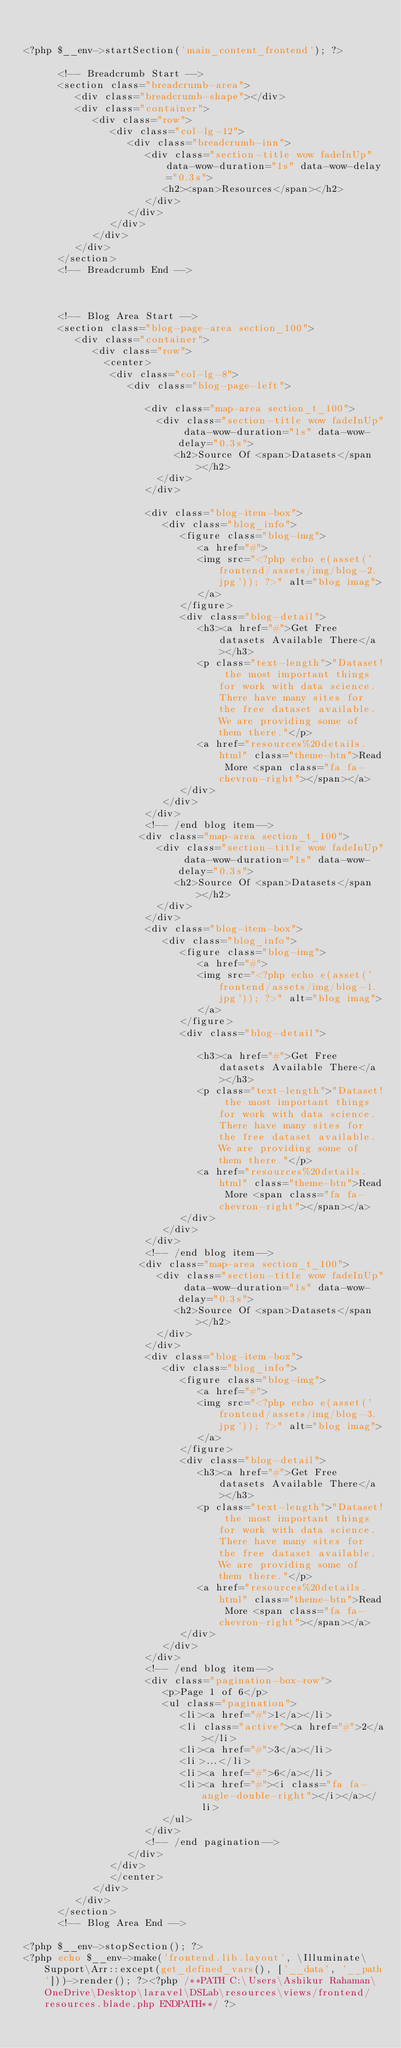Convert code to text. <code><loc_0><loc_0><loc_500><loc_500><_PHP_>

<?php $__env->startSection('main_content_frontend'); ?>

      <!-- Breadcrumb Start -->
      <section class="breadcrumb-area">
         <div class="breadcrumb-shape"></div>
         <div class="container">
            <div class="row">
               <div class="col-lg-12">
                  <div class="breadcrumb-inn">
                     <div class="section-title wow fadeInUp" data-wow-duration="1s" data-wow-delay="0.3s">
                        <h2><span>Resources</span></h2>
                     </div>
                  </div>
               </div>
            </div>
         </div>
      </section>
      <!-- Breadcrumb End -->
       

       
      <!-- Blog Area Start -->
      <section class="blog-page-area section_100">
         <div class="container">
            <div class="row">
              <center>
               <div class="col-lg-8">
                  <div class="blog-page-left">
                    
                     <div class="map-area section_t_100">
                       <div class="section-title wow fadeInUp" data-wow-duration="1s" data-wow-delay="0.3s">
                          <h2>Source Of <span>Datasets</span></h2>
                       </div>
                     </div>
                     
                     <div class="blog-item-box">
                        <div class="blog_info">
                           <figure class="blog-img">
                              <a href="#">
                              <img src="<?php echo e(asset('frontend/assets/img/blog-2.jpg')); ?>" alt="blog imag">
                              </a>
                           </figure>
                           <div class="blog-detail">
                              <h3><a href="#">Get Free datasets Available There</a></h3>
                              <p class="text-length">"Dataset! the most important things for work with data science. There have many sites for the free dataset available. We are providing some of them there."</p>
                              <a href="resources%20details.html" class="theme-btn">Read More <span class="fa fa-chevron-right"></span></a>
                           </div>
                        </div>
                     </div>
                     <!-- /end blog item-->
                    <div class="map-area section_t_100">
                       <div class="section-title wow fadeInUp" data-wow-duration="1s" data-wow-delay="0.3s">
                          <h2>Source Of <span>Datasets</span></h2>
                       </div>
                     </div>
                     <div class="blog-item-box">
                        <div class="blog_info">
                           <figure class="blog-img">
                              <a href="#">
                              <img src="<?php echo e(asset('frontend/assets/img/blog-1.jpg')); ?>" alt="blog imag">
                              </a>
                           </figure>
                           <div class="blog-detail">
                            
                              <h3><a href="#">Get Free datasets Available There</a></h3>
                              <p class="text-length">"Dataset! the most important things for work with data science. There have many sites for the free dataset available. We are providing some of them there."</p>
                              <a href="resources%20details.html" class="theme-btn">Read More <span class="fa fa-chevron-right"></span></a>
                           </div>
                        </div>
                     </div>
                     <!-- /end blog item-->
                    <div class="map-area section_t_100">
                       <div class="section-title wow fadeInUp" data-wow-duration="1s" data-wow-delay="0.3s">
                          <h2>Source Of <span>Datasets</span></h2>
                       </div>
                     </div>
                     <div class="blog-item-box">
                        <div class="blog_info">
                           <figure class="blog-img">
                              <a href="#">
                              <img src="<?php echo e(asset('frontend/assets/img/blog-3.jpg')); ?>" alt="blog imag">
                              </a>
                           </figure>
                           <div class="blog-detail">
                              <h3><a href="#">Get Free datasets Available There</a></h3>
                              <p class="text-length">"Dataset! the most important things for work with data science. There have many sites for the free dataset available. We are providing some of them there."</p>
                              <a href="resources%20details.html" class="theme-btn">Read More <span class="fa fa-chevron-right"></span></a>
                           </div>
                        </div>
                     </div>
                     <!-- /end blog item-->
                     <div class="pagination-box-row">
                        <p>Page 1 of 6</p>
                        <ul class="pagination">
                           <li><a href="#">1</a></li>
                           <li class="active"><a href="#">2</a></li>
                           <li><a href="#">3</a></li>
                           <li>...</li>
                           <li><a href="#">6</a></li>
                           <li><a href="#"><i class="fa fa-angle-double-right"></i></a></li>
                        </ul>
                     </div>
                     <!-- /end pagination-->
                  </div>
               </div>
               </center>
            </div>
         </div>
      </section>
      <!-- Blog Area End -->

<?php $__env->stopSection(); ?>
<?php echo $__env->make('frontend.lib.layout', \Illuminate\Support\Arr::except(get_defined_vars(), ['__data', '__path']))->render(); ?><?php /**PATH C:\Users\Ashikur Rahaman\OneDrive\Desktop\laravel\DSLab\resources\views/frontend/resources.blade.php ENDPATH**/ ?></code> 